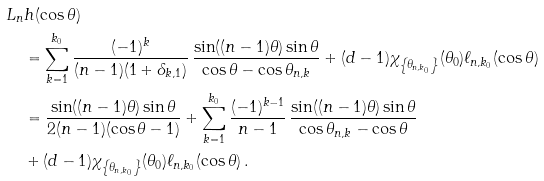<formula> <loc_0><loc_0><loc_500><loc_500>& L _ { n } h ( \cos \theta ) \\ & \quad = \sum ^ { k _ { 0 } } _ { k = 1 } \frac { ( - 1 ) ^ { k } } { ( n - 1 ) ( 1 + \delta _ { k , 1 } ) } \, \frac { \sin ( ( n - 1 ) \theta ) \sin \theta } { \cos \theta - \cos \theta _ { n , k } } + ( d - 1 ) \chi _ { \left \{ \theta _ { n , k _ { 0 } } \right \} } ( \theta _ { 0 } ) \ell _ { n , k _ { 0 } } ( \cos \theta ) \\ & \quad = \frac { \sin ( ( n - 1 ) \theta ) \sin \theta } { 2 ( n - 1 ) ( \cos \theta - 1 ) } + \sum ^ { k _ { 0 } } _ { k = 1 } \frac { ( - 1 ) ^ { k - 1 } } { n - 1 } \, \frac { \sin ( ( n - 1 ) \theta ) \sin \theta } { \cos \theta _ { n , k } - \cos \theta } \\ & \quad + ( d - 1 ) \chi _ { \left \{ \theta _ { n , k _ { 0 } } \right \} } ( \theta _ { 0 } ) \ell _ { n , k _ { 0 } } ( \cos \theta ) \, .</formula> 